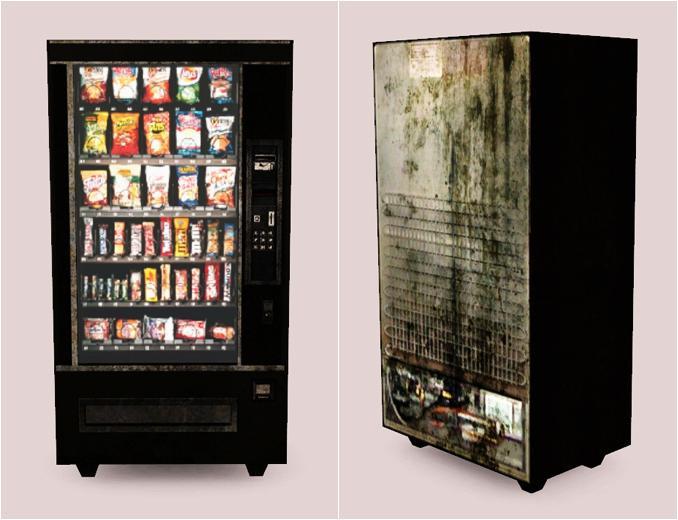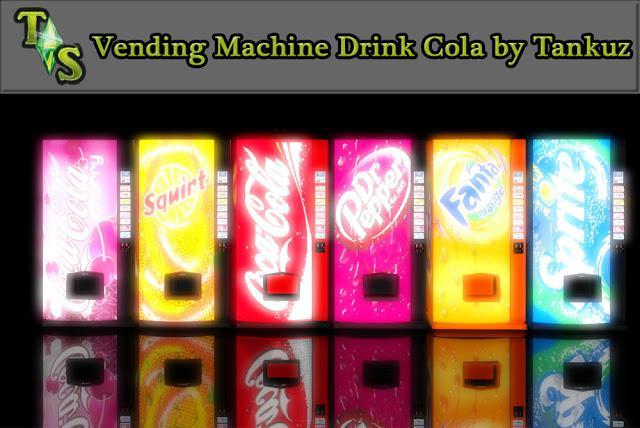The first image is the image on the left, the second image is the image on the right. Analyze the images presented: Is the assertion "Exactly five vending machines are depicted." valid? Answer yes or no. No. 